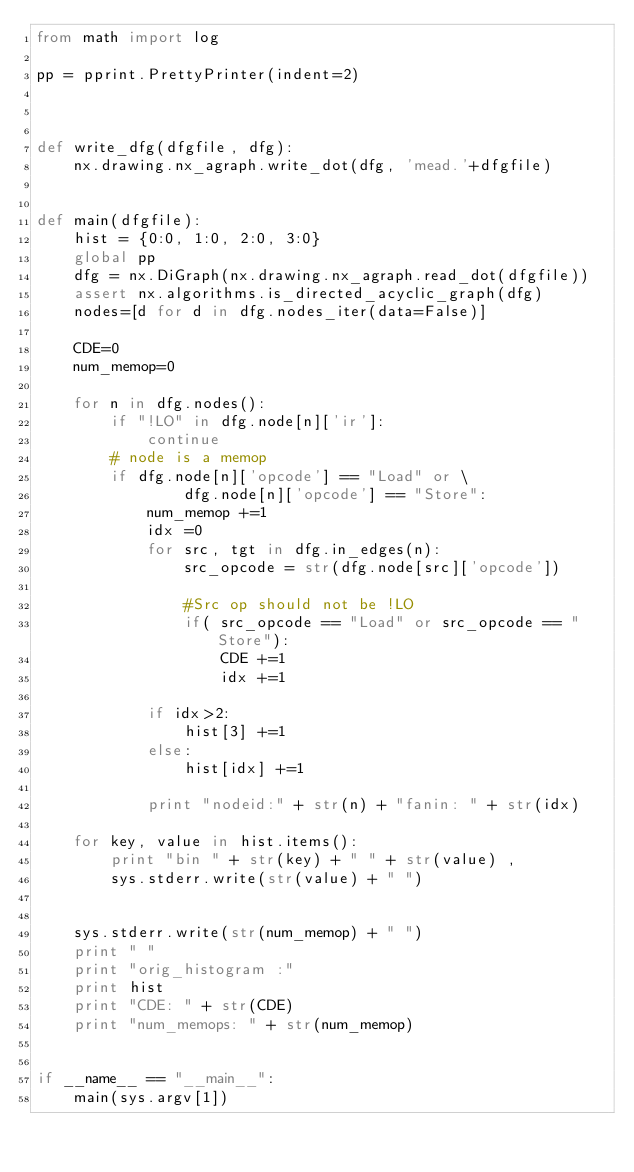Convert code to text. <code><loc_0><loc_0><loc_500><loc_500><_Python_>from math import log

pp = pprint.PrettyPrinter(indent=2)



def write_dfg(dfgfile, dfg):
    nx.drawing.nx_agraph.write_dot(dfg, 'mead.'+dfgfile)


def main(dfgfile):
    hist = {0:0, 1:0, 2:0, 3:0}
    global pp
    dfg = nx.DiGraph(nx.drawing.nx_agraph.read_dot(dfgfile))
    assert nx.algorithms.is_directed_acyclic_graph(dfg) 
    nodes=[d for d in dfg.nodes_iter(data=False)]

    CDE=0
    num_memop=0

    for n in dfg.nodes():
        if "!LO" in dfg.node[n]['ir']:
            continue
        # node is a memop
        if dfg.node[n]['opcode'] == "Load" or \
                dfg.node[n]['opcode'] == "Store": 
            num_memop +=1
            idx =0
            for src, tgt in dfg.in_edges(n):
                src_opcode = str(dfg.node[src]['opcode'])

                #Src op should not be !LO
                if( src_opcode == "Load" or src_opcode == "Store"):
                    CDE +=1
                    idx +=1

            if idx>2:
                hist[3] +=1
            else:
                hist[idx] +=1
            
            print "nodeid:" + str(n) + "fanin: " + str(idx) 

    for key, value in hist.items():
        print "bin " + str(key) + " " + str(value) , 
        sys.stderr.write(str(value) + " ")


    sys.stderr.write(str(num_memop) + " ")
    print " "
    print "orig_histogram :" 
    print hist
    print "CDE: " + str(CDE)
    print "num_memops: " + str(num_memop)


if __name__ == "__main__":
    main(sys.argv[1])
</code> 